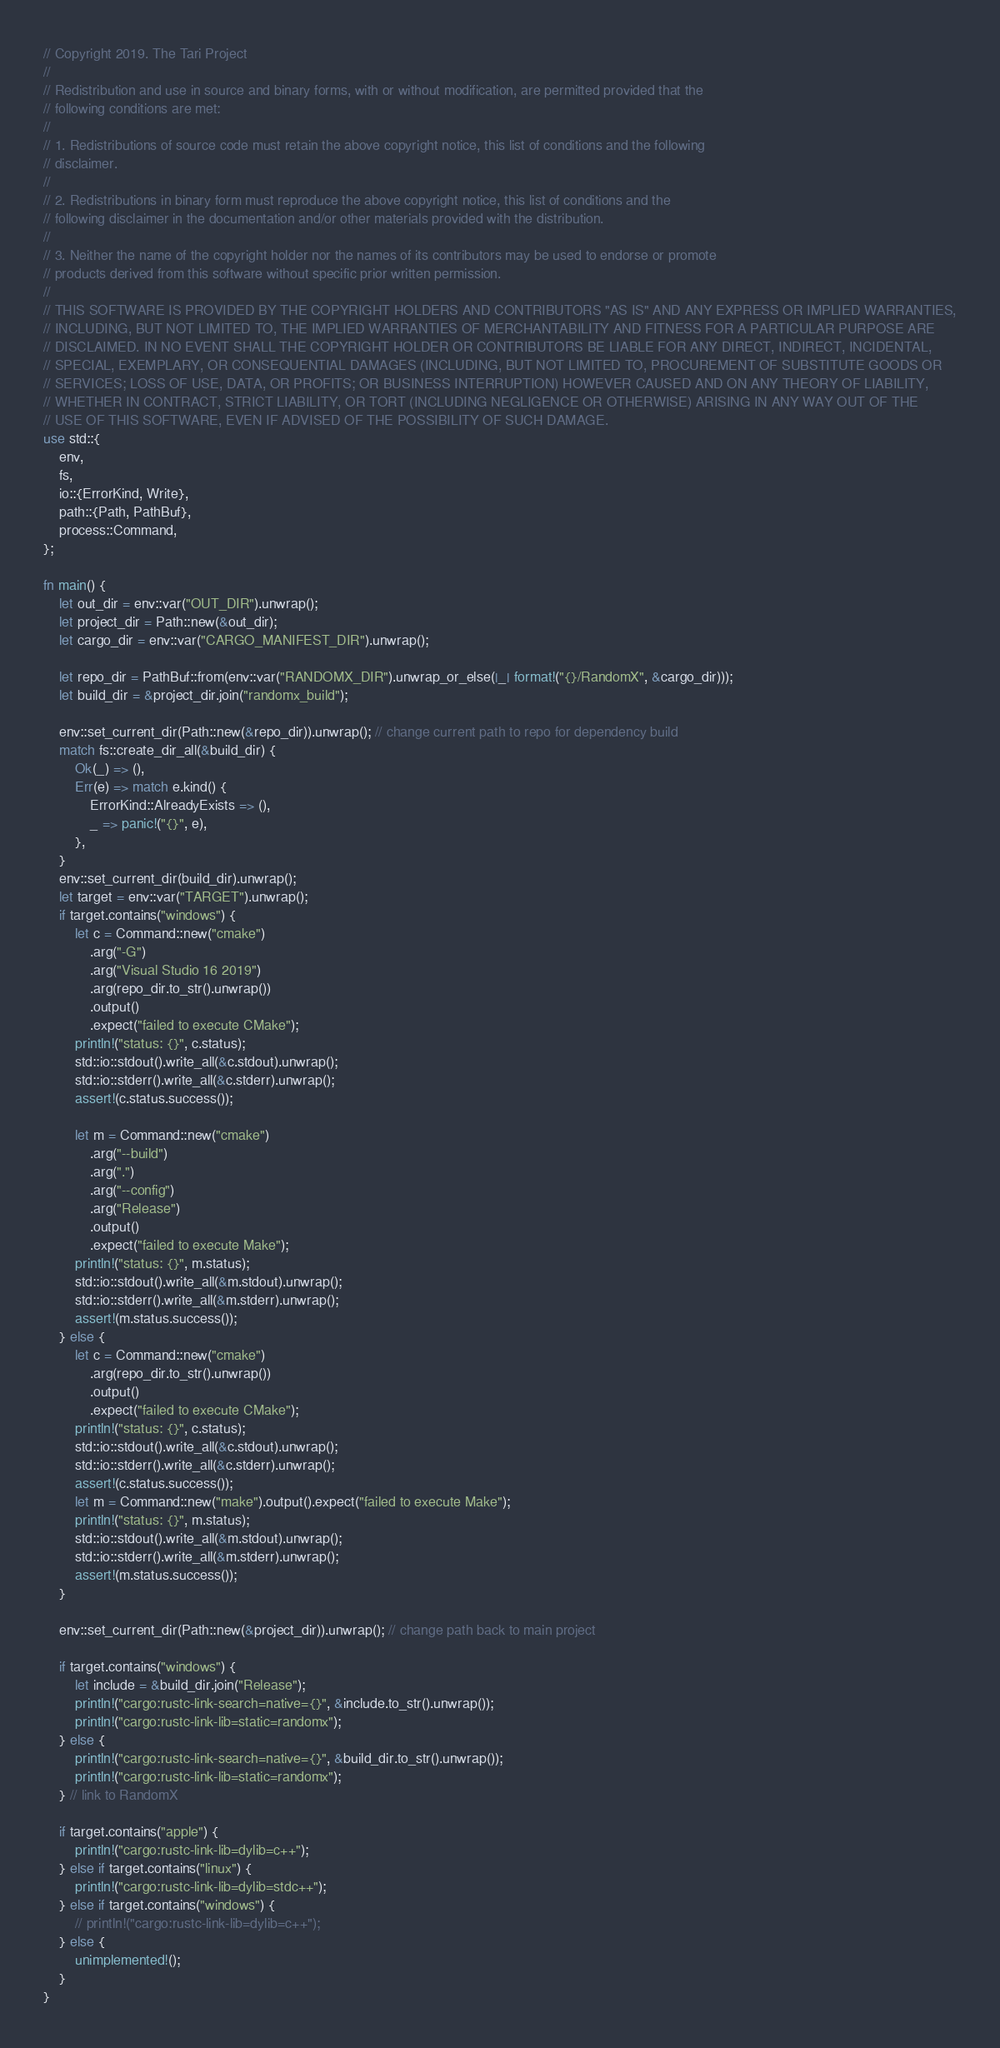<code> <loc_0><loc_0><loc_500><loc_500><_Rust_>// Copyright 2019. The Tari Project
//
// Redistribution and use in source and binary forms, with or without modification, are permitted provided that the
// following conditions are met:
//
// 1. Redistributions of source code must retain the above copyright notice, this list of conditions and the following
// disclaimer.
//
// 2. Redistributions in binary form must reproduce the above copyright notice, this list of conditions and the
// following disclaimer in the documentation and/or other materials provided with the distribution.
//
// 3. Neither the name of the copyright holder nor the names of its contributors may be used to endorse or promote
// products derived from this software without specific prior written permission.
//
// THIS SOFTWARE IS PROVIDED BY THE COPYRIGHT HOLDERS AND CONTRIBUTORS "AS IS" AND ANY EXPRESS OR IMPLIED WARRANTIES,
// INCLUDING, BUT NOT LIMITED TO, THE IMPLIED WARRANTIES OF MERCHANTABILITY AND FITNESS FOR A PARTICULAR PURPOSE ARE
// DISCLAIMED. IN NO EVENT SHALL THE COPYRIGHT HOLDER OR CONTRIBUTORS BE LIABLE FOR ANY DIRECT, INDIRECT, INCIDENTAL,
// SPECIAL, EXEMPLARY, OR CONSEQUENTIAL DAMAGES (INCLUDING, BUT NOT LIMITED TO, PROCUREMENT OF SUBSTITUTE GOODS OR
// SERVICES; LOSS OF USE, DATA, OR PROFITS; OR BUSINESS INTERRUPTION) HOWEVER CAUSED AND ON ANY THEORY OF LIABILITY,
// WHETHER IN CONTRACT, STRICT LIABILITY, OR TORT (INCLUDING NEGLIGENCE OR OTHERWISE) ARISING IN ANY WAY OUT OF THE
// USE OF THIS SOFTWARE, EVEN IF ADVISED OF THE POSSIBILITY OF SUCH DAMAGE.
use std::{
    env,
    fs,
    io::{ErrorKind, Write},
    path::{Path, PathBuf},
    process::Command,
};

fn main() {
    let out_dir = env::var("OUT_DIR").unwrap();
    let project_dir = Path::new(&out_dir);
    let cargo_dir = env::var("CARGO_MANIFEST_DIR").unwrap();

    let repo_dir = PathBuf::from(env::var("RANDOMX_DIR").unwrap_or_else(|_| format!("{}/RandomX", &cargo_dir)));
    let build_dir = &project_dir.join("randomx_build");

    env::set_current_dir(Path::new(&repo_dir)).unwrap(); // change current path to repo for dependency build
    match fs::create_dir_all(&build_dir) {
        Ok(_) => (),
        Err(e) => match e.kind() {
            ErrorKind::AlreadyExists => (),
            _ => panic!("{}", e),
        },
    }
    env::set_current_dir(build_dir).unwrap();
    let target = env::var("TARGET").unwrap();
    if target.contains("windows") {
        let c = Command::new("cmake")
            .arg("-G")
            .arg("Visual Studio 16 2019")
            .arg(repo_dir.to_str().unwrap())
            .output()
            .expect("failed to execute CMake");
        println!("status: {}", c.status);
        std::io::stdout().write_all(&c.stdout).unwrap();
        std::io::stderr().write_all(&c.stderr).unwrap();
        assert!(c.status.success());

        let m = Command::new("cmake")
            .arg("--build")
            .arg(".")
            .arg("--config")
            .arg("Release")
            .output()
            .expect("failed to execute Make");
        println!("status: {}", m.status);
        std::io::stdout().write_all(&m.stdout).unwrap();
        std::io::stderr().write_all(&m.stderr).unwrap();
        assert!(m.status.success());
    } else {
        let c = Command::new("cmake")
            .arg(repo_dir.to_str().unwrap())
            .output()
            .expect("failed to execute CMake");
        println!("status: {}", c.status);
        std::io::stdout().write_all(&c.stdout).unwrap();
        std::io::stderr().write_all(&c.stderr).unwrap();
        assert!(c.status.success());
        let m = Command::new("make").output().expect("failed to execute Make");
        println!("status: {}", m.status);
        std::io::stdout().write_all(&m.stdout).unwrap();
        std::io::stderr().write_all(&m.stderr).unwrap();
        assert!(m.status.success());
    }

    env::set_current_dir(Path::new(&project_dir)).unwrap(); // change path back to main project

    if target.contains("windows") {
        let include = &build_dir.join("Release");
        println!("cargo:rustc-link-search=native={}", &include.to_str().unwrap());
        println!("cargo:rustc-link-lib=static=randomx");
    } else {
        println!("cargo:rustc-link-search=native={}", &build_dir.to_str().unwrap());
        println!("cargo:rustc-link-lib=static=randomx");
    } // link to RandomX

    if target.contains("apple") {
        println!("cargo:rustc-link-lib=dylib=c++");
    } else if target.contains("linux") {
        println!("cargo:rustc-link-lib=dylib=stdc++");
    } else if target.contains("windows") {
        // println!("cargo:rustc-link-lib=dylib=c++");
    } else {
        unimplemented!();
    }
}
</code> 